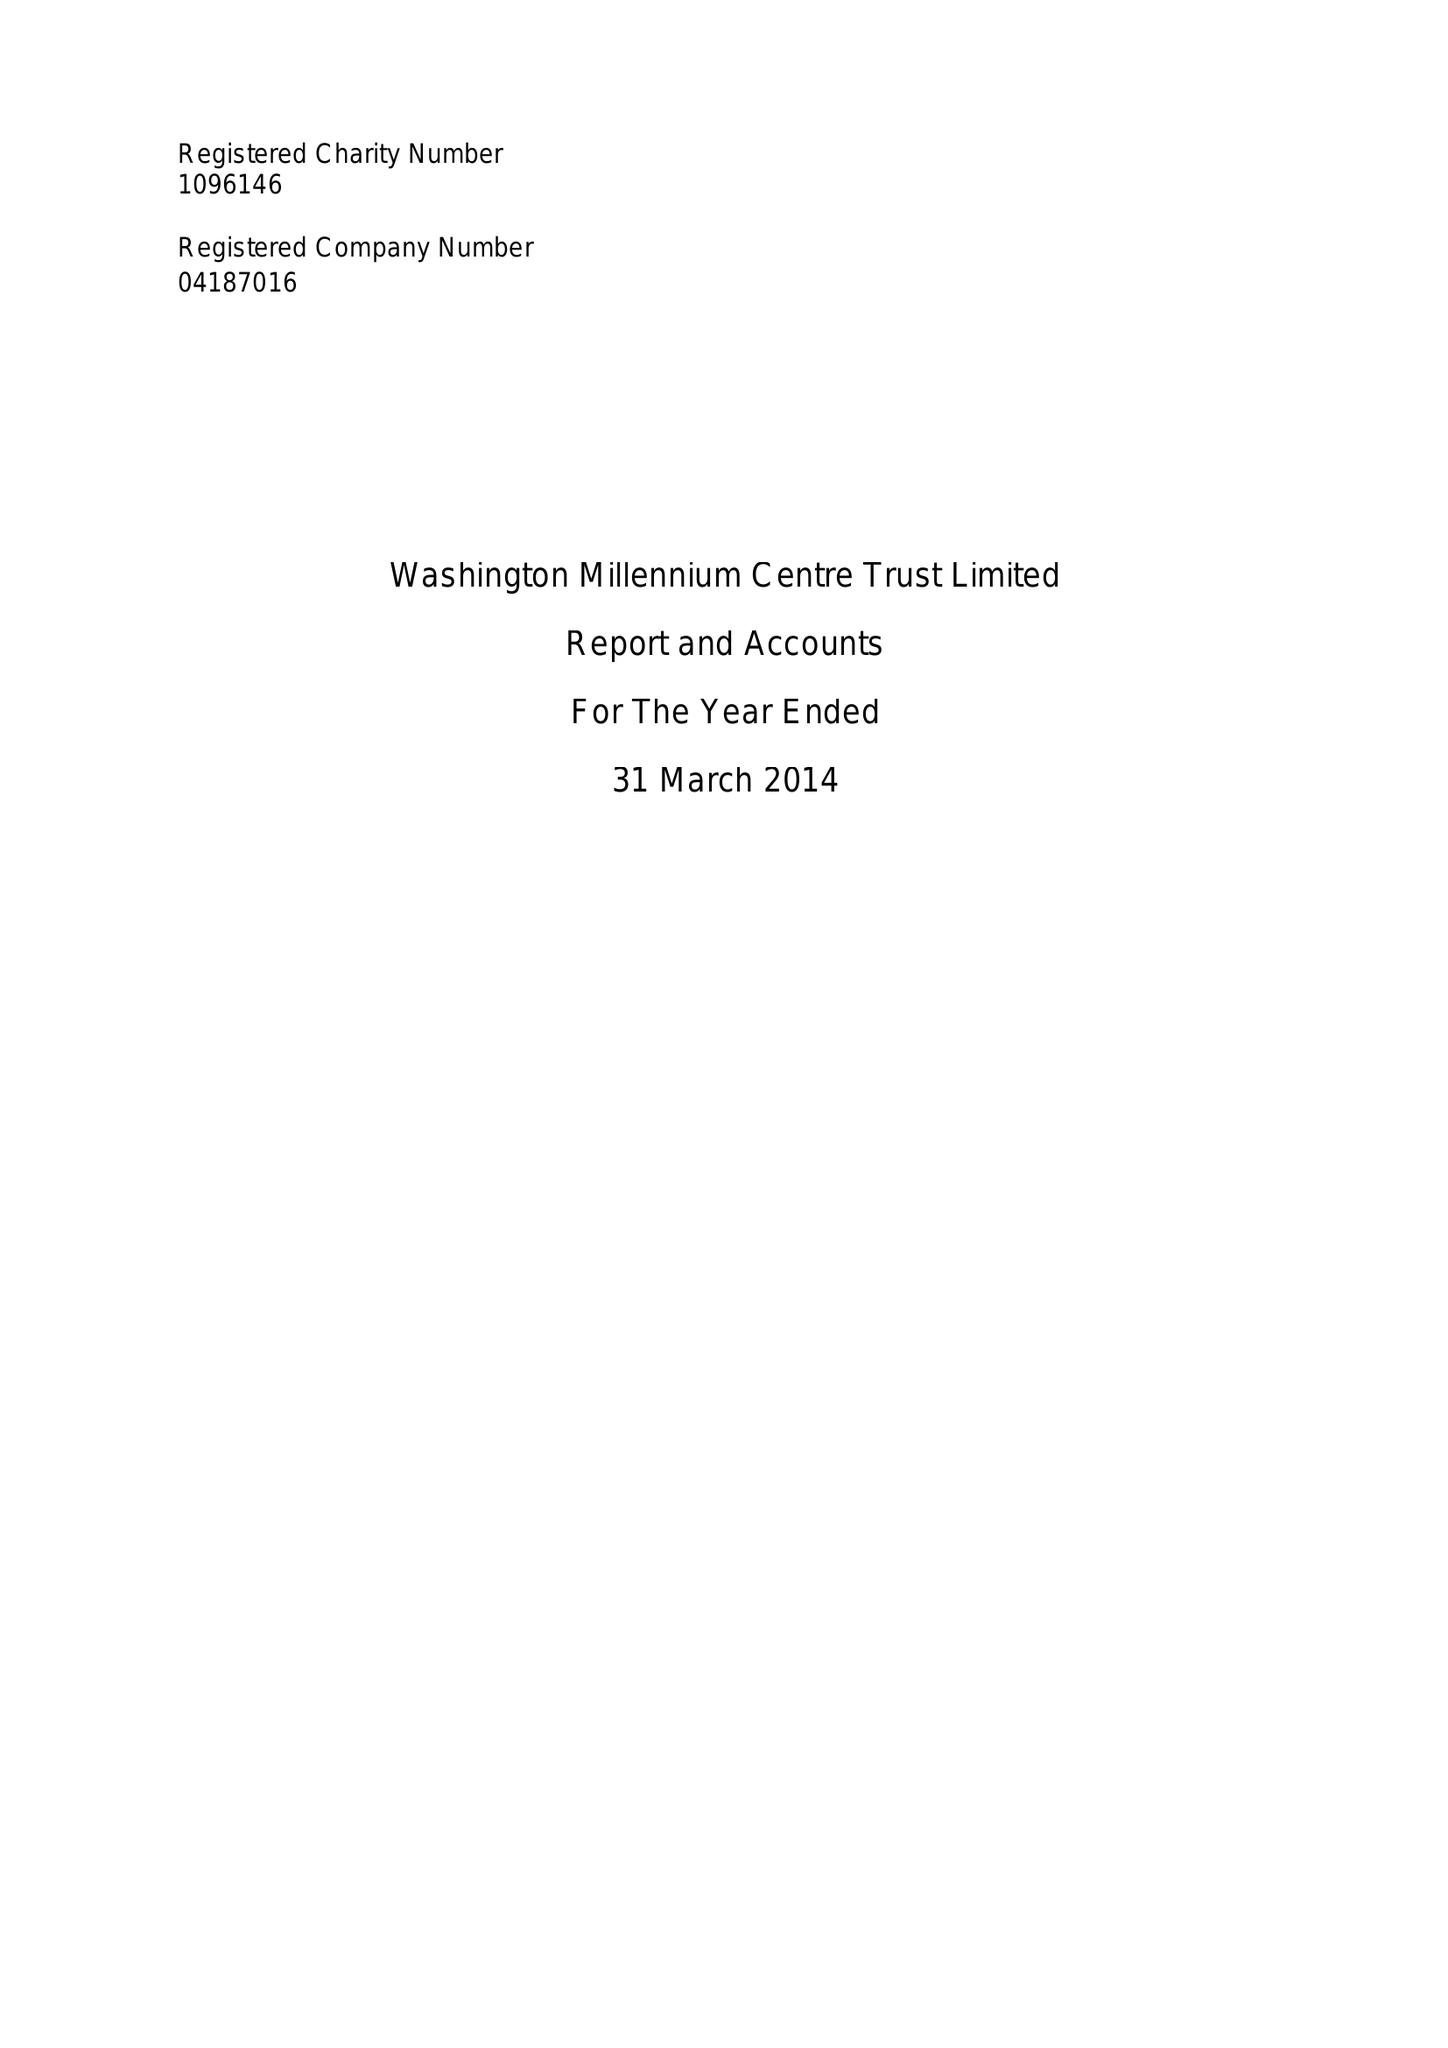What is the value for the income_annually_in_british_pounds?
Answer the question using a single word or phrase. 271800.00 